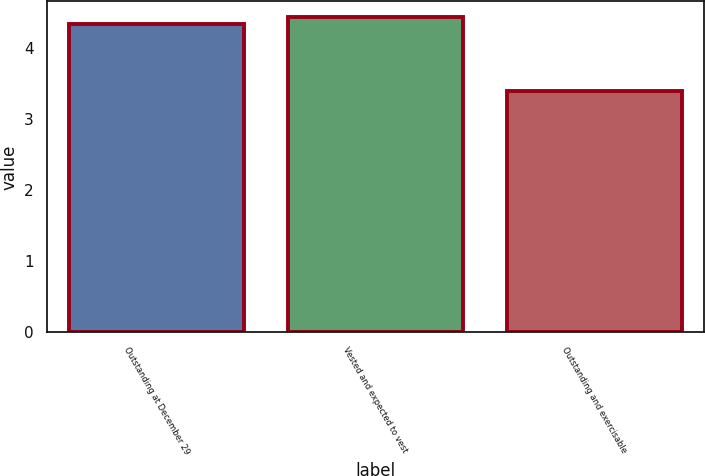<chart> <loc_0><loc_0><loc_500><loc_500><bar_chart><fcel>Outstanding at December 29<fcel>Vested and expected to vest<fcel>Outstanding and exercisable<nl><fcel>4.34<fcel>4.43<fcel>3.4<nl></chart> 